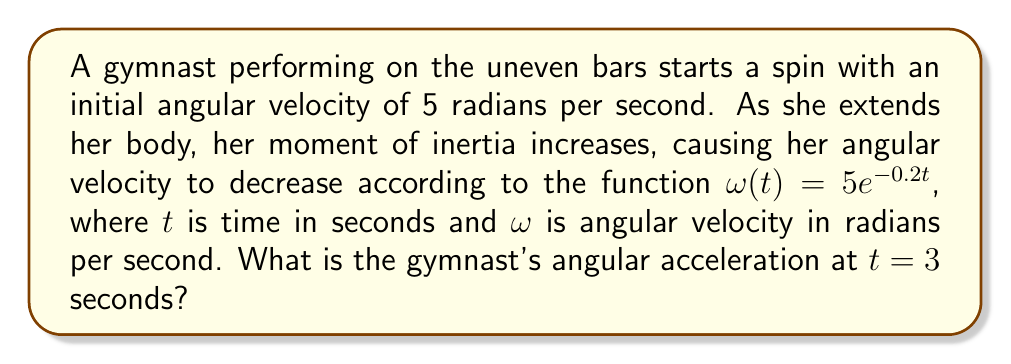Give your solution to this math problem. To find the angular acceleration, we need to differentiate the angular velocity function with respect to time.

Step 1: Given function for angular velocity
$$\omega(t) = 5e^{-0.2t}$$

Step 2: Differentiate $\omega(t)$ to get angular acceleration $\alpha(t)$
$$\alpha(t) = \frac{d\omega}{dt} = \frac{d}{dt}(5e^{-0.2t})$$
$$\alpha(t) = 5 \cdot (-0.2) \cdot e^{-0.2t}$$
$$\alpha(t) = -e^{-0.2t}$$

Step 3: Evaluate $\alpha(t)$ at $t = 3$ seconds
$$\alpha(3) = -e^{-0.2(3)}$$
$$\alpha(3) = -e^{-0.6}$$
$$\alpha(3) \approx -0.549 \text{ rad/s}^2$$

The negative value indicates that the angular acceleration is in the opposite direction of the angular velocity, which aligns with the fact that the gymnast is slowing down.
Answer: $-0.549 \text{ rad/s}^2$ 